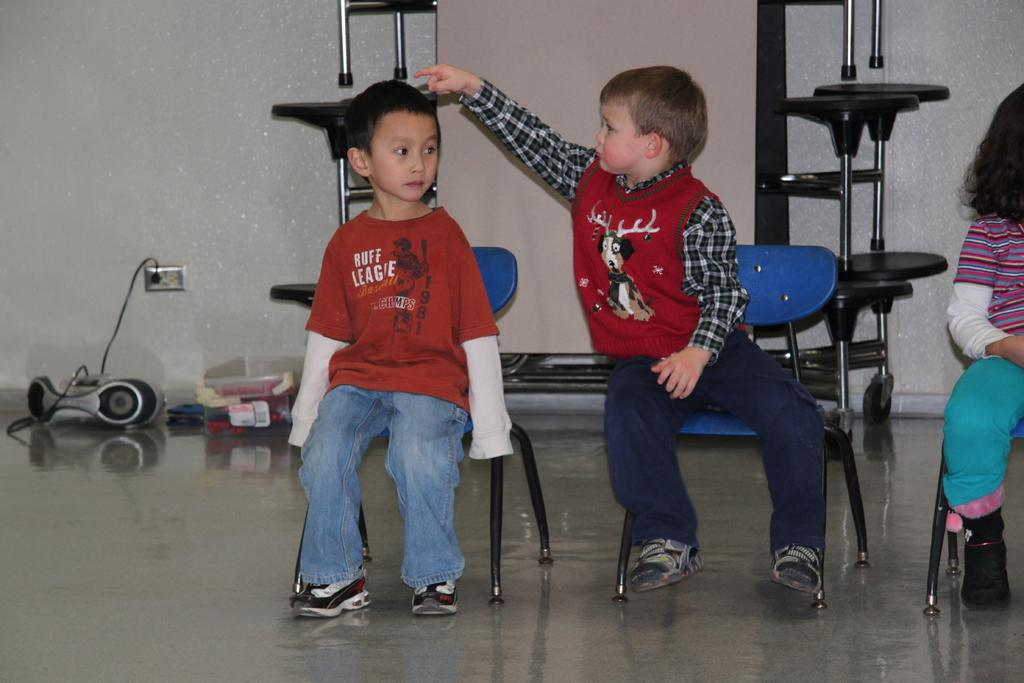What is happening in the center of the image? There is a group of persons sitting on a chair in the center of the image. What can be seen in the background of the image? There is a tape recorder, a container, and stands in the background of the image. What time of day is it in the image, as indicated by the calendar? There is no calendar present in the image, so it is not possible to determine the time of day from the image. 